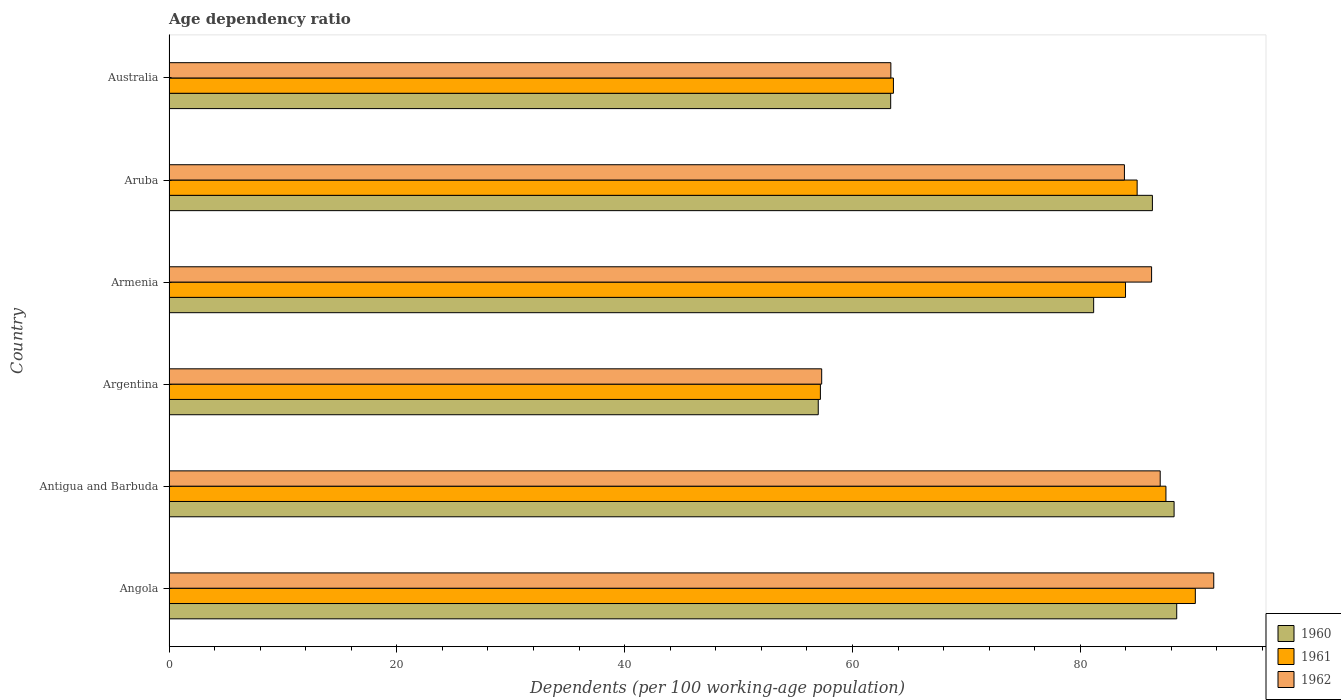Are the number of bars per tick equal to the number of legend labels?
Give a very brief answer. Yes. What is the label of the 2nd group of bars from the top?
Provide a short and direct response. Aruba. What is the age dependency ratio in in 1960 in Angola?
Keep it short and to the point. 88.47. Across all countries, what is the maximum age dependency ratio in in 1960?
Provide a succinct answer. 88.47. Across all countries, what is the minimum age dependency ratio in in 1962?
Provide a succinct answer. 57.3. In which country was the age dependency ratio in in 1960 maximum?
Offer a terse response. Angola. In which country was the age dependency ratio in in 1960 minimum?
Ensure brevity in your answer.  Argentina. What is the total age dependency ratio in in 1960 in the graph?
Your response must be concise. 464.57. What is the difference between the age dependency ratio in in 1961 in Angola and that in Argentina?
Your answer should be compact. 32.92. What is the difference between the age dependency ratio in in 1962 in Aruba and the age dependency ratio in in 1960 in Australia?
Make the answer very short. 20.52. What is the average age dependency ratio in in 1961 per country?
Give a very brief answer. 77.9. What is the difference between the age dependency ratio in in 1962 and age dependency ratio in in 1960 in Angola?
Offer a very short reply. 3.25. In how many countries, is the age dependency ratio in in 1961 greater than 8 %?
Ensure brevity in your answer.  6. What is the ratio of the age dependency ratio in in 1961 in Antigua and Barbuda to that in Aruba?
Offer a terse response. 1.03. Is the difference between the age dependency ratio in in 1962 in Armenia and Australia greater than the difference between the age dependency ratio in in 1960 in Armenia and Australia?
Your answer should be very brief. Yes. What is the difference between the highest and the second highest age dependency ratio in in 1962?
Your response must be concise. 4.7. What is the difference between the highest and the lowest age dependency ratio in in 1962?
Provide a succinct answer. 34.42. In how many countries, is the age dependency ratio in in 1960 greater than the average age dependency ratio in in 1960 taken over all countries?
Ensure brevity in your answer.  4. What does the 3rd bar from the top in Angola represents?
Keep it short and to the point. 1960. Is it the case that in every country, the sum of the age dependency ratio in in 1962 and age dependency ratio in in 1961 is greater than the age dependency ratio in in 1960?
Ensure brevity in your answer.  Yes. How many bars are there?
Your response must be concise. 18. Are the values on the major ticks of X-axis written in scientific E-notation?
Your answer should be compact. No. Does the graph contain any zero values?
Give a very brief answer. No. Does the graph contain grids?
Provide a succinct answer. No. How many legend labels are there?
Your answer should be compact. 3. What is the title of the graph?
Ensure brevity in your answer.  Age dependency ratio. What is the label or title of the X-axis?
Ensure brevity in your answer.  Dependents (per 100 working-age population). What is the Dependents (per 100 working-age population) in 1960 in Angola?
Keep it short and to the point. 88.47. What is the Dependents (per 100 working-age population) of 1961 in Angola?
Offer a terse response. 90.1. What is the Dependents (per 100 working-age population) in 1962 in Angola?
Provide a succinct answer. 91.72. What is the Dependents (per 100 working-age population) in 1960 in Antigua and Barbuda?
Give a very brief answer. 88.24. What is the Dependents (per 100 working-age population) in 1961 in Antigua and Barbuda?
Offer a very short reply. 87.52. What is the Dependents (per 100 working-age population) of 1962 in Antigua and Barbuda?
Provide a short and direct response. 87.02. What is the Dependents (per 100 working-age population) of 1960 in Argentina?
Offer a terse response. 57. What is the Dependents (per 100 working-age population) of 1961 in Argentina?
Your response must be concise. 57.19. What is the Dependents (per 100 working-age population) of 1962 in Argentina?
Make the answer very short. 57.3. What is the Dependents (per 100 working-age population) in 1960 in Armenia?
Provide a succinct answer. 81.18. What is the Dependents (per 100 working-age population) in 1961 in Armenia?
Your answer should be compact. 83.97. What is the Dependents (per 100 working-age population) in 1962 in Armenia?
Give a very brief answer. 86.26. What is the Dependents (per 100 working-age population) of 1960 in Aruba?
Give a very brief answer. 86.33. What is the Dependents (per 100 working-age population) in 1961 in Aruba?
Your answer should be very brief. 84.99. What is the Dependents (per 100 working-age population) in 1962 in Aruba?
Your answer should be very brief. 83.88. What is the Dependents (per 100 working-age population) in 1960 in Australia?
Keep it short and to the point. 63.36. What is the Dependents (per 100 working-age population) in 1961 in Australia?
Give a very brief answer. 63.6. What is the Dependents (per 100 working-age population) in 1962 in Australia?
Make the answer very short. 63.37. Across all countries, what is the maximum Dependents (per 100 working-age population) of 1960?
Provide a short and direct response. 88.47. Across all countries, what is the maximum Dependents (per 100 working-age population) in 1961?
Your answer should be very brief. 90.1. Across all countries, what is the maximum Dependents (per 100 working-age population) of 1962?
Offer a very short reply. 91.72. Across all countries, what is the minimum Dependents (per 100 working-age population) in 1960?
Offer a terse response. 57. Across all countries, what is the minimum Dependents (per 100 working-age population) in 1961?
Keep it short and to the point. 57.19. Across all countries, what is the minimum Dependents (per 100 working-age population) in 1962?
Keep it short and to the point. 57.3. What is the total Dependents (per 100 working-age population) of 1960 in the graph?
Give a very brief answer. 464.57. What is the total Dependents (per 100 working-age population) in 1961 in the graph?
Your response must be concise. 467.37. What is the total Dependents (per 100 working-age population) in 1962 in the graph?
Keep it short and to the point. 469.55. What is the difference between the Dependents (per 100 working-age population) in 1960 in Angola and that in Antigua and Barbuda?
Your answer should be very brief. 0.23. What is the difference between the Dependents (per 100 working-age population) of 1961 in Angola and that in Antigua and Barbuda?
Make the answer very short. 2.58. What is the difference between the Dependents (per 100 working-age population) in 1962 in Angola and that in Antigua and Barbuda?
Make the answer very short. 4.7. What is the difference between the Dependents (per 100 working-age population) in 1960 in Angola and that in Argentina?
Offer a terse response. 31.47. What is the difference between the Dependents (per 100 working-age population) in 1961 in Angola and that in Argentina?
Your answer should be very brief. 32.92. What is the difference between the Dependents (per 100 working-age population) of 1962 in Angola and that in Argentina?
Offer a terse response. 34.42. What is the difference between the Dependents (per 100 working-age population) of 1960 in Angola and that in Armenia?
Your answer should be very brief. 7.29. What is the difference between the Dependents (per 100 working-age population) of 1961 in Angola and that in Armenia?
Provide a short and direct response. 6.13. What is the difference between the Dependents (per 100 working-age population) in 1962 in Angola and that in Armenia?
Make the answer very short. 5.46. What is the difference between the Dependents (per 100 working-age population) of 1960 in Angola and that in Aruba?
Keep it short and to the point. 2.13. What is the difference between the Dependents (per 100 working-age population) in 1961 in Angola and that in Aruba?
Keep it short and to the point. 5.11. What is the difference between the Dependents (per 100 working-age population) in 1962 in Angola and that in Aruba?
Your response must be concise. 7.84. What is the difference between the Dependents (per 100 working-age population) in 1960 in Angola and that in Australia?
Ensure brevity in your answer.  25.11. What is the difference between the Dependents (per 100 working-age population) in 1961 in Angola and that in Australia?
Your response must be concise. 26.5. What is the difference between the Dependents (per 100 working-age population) in 1962 in Angola and that in Australia?
Your response must be concise. 28.35. What is the difference between the Dependents (per 100 working-age population) in 1960 in Antigua and Barbuda and that in Argentina?
Your answer should be compact. 31.24. What is the difference between the Dependents (per 100 working-age population) of 1961 in Antigua and Barbuda and that in Argentina?
Keep it short and to the point. 30.34. What is the difference between the Dependents (per 100 working-age population) of 1962 in Antigua and Barbuda and that in Argentina?
Offer a very short reply. 29.72. What is the difference between the Dependents (per 100 working-age population) of 1960 in Antigua and Barbuda and that in Armenia?
Offer a terse response. 7.06. What is the difference between the Dependents (per 100 working-age population) of 1961 in Antigua and Barbuda and that in Armenia?
Provide a short and direct response. 3.55. What is the difference between the Dependents (per 100 working-age population) in 1962 in Antigua and Barbuda and that in Armenia?
Your answer should be very brief. 0.76. What is the difference between the Dependents (per 100 working-age population) of 1960 in Antigua and Barbuda and that in Aruba?
Your response must be concise. 1.9. What is the difference between the Dependents (per 100 working-age population) of 1961 in Antigua and Barbuda and that in Aruba?
Offer a terse response. 2.53. What is the difference between the Dependents (per 100 working-age population) in 1962 in Antigua and Barbuda and that in Aruba?
Your answer should be very brief. 3.14. What is the difference between the Dependents (per 100 working-age population) of 1960 in Antigua and Barbuda and that in Australia?
Your response must be concise. 24.88. What is the difference between the Dependents (per 100 working-age population) in 1961 in Antigua and Barbuda and that in Australia?
Your answer should be compact. 23.92. What is the difference between the Dependents (per 100 working-age population) of 1962 in Antigua and Barbuda and that in Australia?
Offer a very short reply. 23.65. What is the difference between the Dependents (per 100 working-age population) of 1960 in Argentina and that in Armenia?
Ensure brevity in your answer.  -24.18. What is the difference between the Dependents (per 100 working-age population) of 1961 in Argentina and that in Armenia?
Offer a terse response. -26.79. What is the difference between the Dependents (per 100 working-age population) in 1962 in Argentina and that in Armenia?
Offer a terse response. -28.96. What is the difference between the Dependents (per 100 working-age population) of 1960 in Argentina and that in Aruba?
Ensure brevity in your answer.  -29.34. What is the difference between the Dependents (per 100 working-age population) in 1961 in Argentina and that in Aruba?
Keep it short and to the point. -27.81. What is the difference between the Dependents (per 100 working-age population) in 1962 in Argentina and that in Aruba?
Provide a short and direct response. -26.58. What is the difference between the Dependents (per 100 working-age population) in 1960 in Argentina and that in Australia?
Provide a succinct answer. -6.36. What is the difference between the Dependents (per 100 working-age population) in 1961 in Argentina and that in Australia?
Your answer should be very brief. -6.41. What is the difference between the Dependents (per 100 working-age population) of 1962 in Argentina and that in Australia?
Ensure brevity in your answer.  -6.07. What is the difference between the Dependents (per 100 working-age population) in 1960 in Armenia and that in Aruba?
Your answer should be compact. -5.16. What is the difference between the Dependents (per 100 working-age population) of 1961 in Armenia and that in Aruba?
Offer a terse response. -1.02. What is the difference between the Dependents (per 100 working-age population) of 1962 in Armenia and that in Aruba?
Provide a succinct answer. 2.39. What is the difference between the Dependents (per 100 working-age population) in 1960 in Armenia and that in Australia?
Provide a short and direct response. 17.82. What is the difference between the Dependents (per 100 working-age population) in 1961 in Armenia and that in Australia?
Offer a very short reply. 20.38. What is the difference between the Dependents (per 100 working-age population) in 1962 in Armenia and that in Australia?
Keep it short and to the point. 22.89. What is the difference between the Dependents (per 100 working-age population) in 1960 in Aruba and that in Australia?
Provide a short and direct response. 22.98. What is the difference between the Dependents (per 100 working-age population) of 1961 in Aruba and that in Australia?
Ensure brevity in your answer.  21.4. What is the difference between the Dependents (per 100 working-age population) in 1962 in Aruba and that in Australia?
Ensure brevity in your answer.  20.5. What is the difference between the Dependents (per 100 working-age population) of 1960 in Angola and the Dependents (per 100 working-age population) of 1961 in Antigua and Barbuda?
Provide a short and direct response. 0.95. What is the difference between the Dependents (per 100 working-age population) of 1960 in Angola and the Dependents (per 100 working-age population) of 1962 in Antigua and Barbuda?
Provide a succinct answer. 1.45. What is the difference between the Dependents (per 100 working-age population) of 1961 in Angola and the Dependents (per 100 working-age population) of 1962 in Antigua and Barbuda?
Provide a succinct answer. 3.08. What is the difference between the Dependents (per 100 working-age population) of 1960 in Angola and the Dependents (per 100 working-age population) of 1961 in Argentina?
Your answer should be very brief. 31.28. What is the difference between the Dependents (per 100 working-age population) in 1960 in Angola and the Dependents (per 100 working-age population) in 1962 in Argentina?
Your answer should be very brief. 31.17. What is the difference between the Dependents (per 100 working-age population) of 1961 in Angola and the Dependents (per 100 working-age population) of 1962 in Argentina?
Offer a terse response. 32.8. What is the difference between the Dependents (per 100 working-age population) of 1960 in Angola and the Dependents (per 100 working-age population) of 1961 in Armenia?
Your response must be concise. 4.49. What is the difference between the Dependents (per 100 working-age population) of 1960 in Angola and the Dependents (per 100 working-age population) of 1962 in Armenia?
Offer a terse response. 2.21. What is the difference between the Dependents (per 100 working-age population) of 1961 in Angola and the Dependents (per 100 working-age population) of 1962 in Armenia?
Offer a terse response. 3.84. What is the difference between the Dependents (per 100 working-age population) in 1960 in Angola and the Dependents (per 100 working-age population) in 1961 in Aruba?
Your answer should be compact. 3.47. What is the difference between the Dependents (per 100 working-age population) of 1960 in Angola and the Dependents (per 100 working-age population) of 1962 in Aruba?
Offer a very short reply. 4.59. What is the difference between the Dependents (per 100 working-age population) in 1961 in Angola and the Dependents (per 100 working-age population) in 1962 in Aruba?
Keep it short and to the point. 6.22. What is the difference between the Dependents (per 100 working-age population) in 1960 in Angola and the Dependents (per 100 working-age population) in 1961 in Australia?
Offer a very short reply. 24.87. What is the difference between the Dependents (per 100 working-age population) in 1960 in Angola and the Dependents (per 100 working-age population) in 1962 in Australia?
Make the answer very short. 25.1. What is the difference between the Dependents (per 100 working-age population) of 1961 in Angola and the Dependents (per 100 working-age population) of 1962 in Australia?
Give a very brief answer. 26.73. What is the difference between the Dependents (per 100 working-age population) of 1960 in Antigua and Barbuda and the Dependents (per 100 working-age population) of 1961 in Argentina?
Provide a succinct answer. 31.05. What is the difference between the Dependents (per 100 working-age population) in 1960 in Antigua and Barbuda and the Dependents (per 100 working-age population) in 1962 in Argentina?
Keep it short and to the point. 30.94. What is the difference between the Dependents (per 100 working-age population) of 1961 in Antigua and Barbuda and the Dependents (per 100 working-age population) of 1962 in Argentina?
Your answer should be very brief. 30.22. What is the difference between the Dependents (per 100 working-age population) of 1960 in Antigua and Barbuda and the Dependents (per 100 working-age population) of 1961 in Armenia?
Your answer should be compact. 4.26. What is the difference between the Dependents (per 100 working-age population) in 1960 in Antigua and Barbuda and the Dependents (per 100 working-age population) in 1962 in Armenia?
Offer a very short reply. 1.97. What is the difference between the Dependents (per 100 working-age population) in 1961 in Antigua and Barbuda and the Dependents (per 100 working-age population) in 1962 in Armenia?
Provide a succinct answer. 1.26. What is the difference between the Dependents (per 100 working-age population) in 1960 in Antigua and Barbuda and the Dependents (per 100 working-age population) in 1961 in Aruba?
Provide a succinct answer. 3.24. What is the difference between the Dependents (per 100 working-age population) in 1960 in Antigua and Barbuda and the Dependents (per 100 working-age population) in 1962 in Aruba?
Offer a very short reply. 4.36. What is the difference between the Dependents (per 100 working-age population) of 1961 in Antigua and Barbuda and the Dependents (per 100 working-age population) of 1962 in Aruba?
Make the answer very short. 3.64. What is the difference between the Dependents (per 100 working-age population) in 1960 in Antigua and Barbuda and the Dependents (per 100 working-age population) in 1961 in Australia?
Provide a succinct answer. 24.64. What is the difference between the Dependents (per 100 working-age population) in 1960 in Antigua and Barbuda and the Dependents (per 100 working-age population) in 1962 in Australia?
Provide a short and direct response. 24.86. What is the difference between the Dependents (per 100 working-age population) in 1961 in Antigua and Barbuda and the Dependents (per 100 working-age population) in 1962 in Australia?
Provide a short and direct response. 24.15. What is the difference between the Dependents (per 100 working-age population) of 1960 in Argentina and the Dependents (per 100 working-age population) of 1961 in Armenia?
Your answer should be very brief. -26.98. What is the difference between the Dependents (per 100 working-age population) in 1960 in Argentina and the Dependents (per 100 working-age population) in 1962 in Armenia?
Offer a terse response. -29.27. What is the difference between the Dependents (per 100 working-age population) in 1961 in Argentina and the Dependents (per 100 working-age population) in 1962 in Armenia?
Your answer should be compact. -29.08. What is the difference between the Dependents (per 100 working-age population) of 1960 in Argentina and the Dependents (per 100 working-age population) of 1961 in Aruba?
Your response must be concise. -28. What is the difference between the Dependents (per 100 working-age population) of 1960 in Argentina and the Dependents (per 100 working-age population) of 1962 in Aruba?
Provide a short and direct response. -26.88. What is the difference between the Dependents (per 100 working-age population) of 1961 in Argentina and the Dependents (per 100 working-age population) of 1962 in Aruba?
Offer a terse response. -26.69. What is the difference between the Dependents (per 100 working-age population) of 1960 in Argentina and the Dependents (per 100 working-age population) of 1961 in Australia?
Your answer should be very brief. -6.6. What is the difference between the Dependents (per 100 working-age population) of 1960 in Argentina and the Dependents (per 100 working-age population) of 1962 in Australia?
Make the answer very short. -6.38. What is the difference between the Dependents (per 100 working-age population) of 1961 in Argentina and the Dependents (per 100 working-age population) of 1962 in Australia?
Make the answer very short. -6.19. What is the difference between the Dependents (per 100 working-age population) of 1960 in Armenia and the Dependents (per 100 working-age population) of 1961 in Aruba?
Keep it short and to the point. -3.82. What is the difference between the Dependents (per 100 working-age population) in 1960 in Armenia and the Dependents (per 100 working-age population) in 1962 in Aruba?
Ensure brevity in your answer.  -2.7. What is the difference between the Dependents (per 100 working-age population) in 1961 in Armenia and the Dependents (per 100 working-age population) in 1962 in Aruba?
Provide a short and direct response. 0.1. What is the difference between the Dependents (per 100 working-age population) of 1960 in Armenia and the Dependents (per 100 working-age population) of 1961 in Australia?
Make the answer very short. 17.58. What is the difference between the Dependents (per 100 working-age population) in 1960 in Armenia and the Dependents (per 100 working-age population) in 1962 in Australia?
Your answer should be very brief. 17.8. What is the difference between the Dependents (per 100 working-age population) of 1961 in Armenia and the Dependents (per 100 working-age population) of 1962 in Australia?
Keep it short and to the point. 20.6. What is the difference between the Dependents (per 100 working-age population) in 1960 in Aruba and the Dependents (per 100 working-age population) in 1961 in Australia?
Provide a succinct answer. 22.74. What is the difference between the Dependents (per 100 working-age population) of 1960 in Aruba and the Dependents (per 100 working-age population) of 1962 in Australia?
Provide a short and direct response. 22.96. What is the difference between the Dependents (per 100 working-age population) of 1961 in Aruba and the Dependents (per 100 working-age population) of 1962 in Australia?
Ensure brevity in your answer.  21.62. What is the average Dependents (per 100 working-age population) of 1960 per country?
Offer a very short reply. 77.43. What is the average Dependents (per 100 working-age population) of 1961 per country?
Make the answer very short. 77.89. What is the average Dependents (per 100 working-age population) in 1962 per country?
Ensure brevity in your answer.  78.26. What is the difference between the Dependents (per 100 working-age population) in 1960 and Dependents (per 100 working-age population) in 1961 in Angola?
Your answer should be compact. -1.63. What is the difference between the Dependents (per 100 working-age population) of 1960 and Dependents (per 100 working-age population) of 1962 in Angola?
Keep it short and to the point. -3.25. What is the difference between the Dependents (per 100 working-age population) of 1961 and Dependents (per 100 working-age population) of 1962 in Angola?
Your response must be concise. -1.62. What is the difference between the Dependents (per 100 working-age population) of 1960 and Dependents (per 100 working-age population) of 1961 in Antigua and Barbuda?
Your response must be concise. 0.72. What is the difference between the Dependents (per 100 working-age population) of 1960 and Dependents (per 100 working-age population) of 1962 in Antigua and Barbuda?
Your answer should be very brief. 1.22. What is the difference between the Dependents (per 100 working-age population) in 1961 and Dependents (per 100 working-age population) in 1962 in Antigua and Barbuda?
Keep it short and to the point. 0.5. What is the difference between the Dependents (per 100 working-age population) in 1960 and Dependents (per 100 working-age population) in 1961 in Argentina?
Give a very brief answer. -0.19. What is the difference between the Dependents (per 100 working-age population) in 1960 and Dependents (per 100 working-age population) in 1962 in Argentina?
Ensure brevity in your answer.  -0.3. What is the difference between the Dependents (per 100 working-age population) of 1961 and Dependents (per 100 working-age population) of 1962 in Argentina?
Your answer should be very brief. -0.11. What is the difference between the Dependents (per 100 working-age population) in 1960 and Dependents (per 100 working-age population) in 1961 in Armenia?
Your answer should be very brief. -2.8. What is the difference between the Dependents (per 100 working-age population) of 1960 and Dependents (per 100 working-age population) of 1962 in Armenia?
Your answer should be compact. -5.09. What is the difference between the Dependents (per 100 working-age population) in 1961 and Dependents (per 100 working-age population) in 1962 in Armenia?
Your answer should be very brief. -2.29. What is the difference between the Dependents (per 100 working-age population) of 1960 and Dependents (per 100 working-age population) of 1961 in Aruba?
Keep it short and to the point. 1.34. What is the difference between the Dependents (per 100 working-age population) in 1960 and Dependents (per 100 working-age population) in 1962 in Aruba?
Provide a short and direct response. 2.46. What is the difference between the Dependents (per 100 working-age population) in 1961 and Dependents (per 100 working-age population) in 1962 in Aruba?
Ensure brevity in your answer.  1.12. What is the difference between the Dependents (per 100 working-age population) of 1960 and Dependents (per 100 working-age population) of 1961 in Australia?
Your response must be concise. -0.24. What is the difference between the Dependents (per 100 working-age population) of 1960 and Dependents (per 100 working-age population) of 1962 in Australia?
Keep it short and to the point. -0.02. What is the difference between the Dependents (per 100 working-age population) in 1961 and Dependents (per 100 working-age population) in 1962 in Australia?
Make the answer very short. 0.22. What is the ratio of the Dependents (per 100 working-age population) in 1960 in Angola to that in Antigua and Barbuda?
Ensure brevity in your answer.  1. What is the ratio of the Dependents (per 100 working-age population) in 1961 in Angola to that in Antigua and Barbuda?
Provide a succinct answer. 1.03. What is the ratio of the Dependents (per 100 working-age population) in 1962 in Angola to that in Antigua and Barbuda?
Your answer should be compact. 1.05. What is the ratio of the Dependents (per 100 working-age population) in 1960 in Angola to that in Argentina?
Offer a terse response. 1.55. What is the ratio of the Dependents (per 100 working-age population) in 1961 in Angola to that in Argentina?
Provide a succinct answer. 1.58. What is the ratio of the Dependents (per 100 working-age population) in 1962 in Angola to that in Argentina?
Your response must be concise. 1.6. What is the ratio of the Dependents (per 100 working-age population) of 1960 in Angola to that in Armenia?
Offer a terse response. 1.09. What is the ratio of the Dependents (per 100 working-age population) in 1961 in Angola to that in Armenia?
Your response must be concise. 1.07. What is the ratio of the Dependents (per 100 working-age population) in 1962 in Angola to that in Armenia?
Offer a terse response. 1.06. What is the ratio of the Dependents (per 100 working-age population) of 1960 in Angola to that in Aruba?
Keep it short and to the point. 1.02. What is the ratio of the Dependents (per 100 working-age population) in 1961 in Angola to that in Aruba?
Your answer should be very brief. 1.06. What is the ratio of the Dependents (per 100 working-age population) of 1962 in Angola to that in Aruba?
Provide a succinct answer. 1.09. What is the ratio of the Dependents (per 100 working-age population) in 1960 in Angola to that in Australia?
Your answer should be very brief. 1.4. What is the ratio of the Dependents (per 100 working-age population) in 1961 in Angola to that in Australia?
Make the answer very short. 1.42. What is the ratio of the Dependents (per 100 working-age population) in 1962 in Angola to that in Australia?
Give a very brief answer. 1.45. What is the ratio of the Dependents (per 100 working-age population) in 1960 in Antigua and Barbuda to that in Argentina?
Offer a terse response. 1.55. What is the ratio of the Dependents (per 100 working-age population) of 1961 in Antigua and Barbuda to that in Argentina?
Provide a succinct answer. 1.53. What is the ratio of the Dependents (per 100 working-age population) in 1962 in Antigua and Barbuda to that in Argentina?
Your answer should be very brief. 1.52. What is the ratio of the Dependents (per 100 working-age population) in 1960 in Antigua and Barbuda to that in Armenia?
Give a very brief answer. 1.09. What is the ratio of the Dependents (per 100 working-age population) of 1961 in Antigua and Barbuda to that in Armenia?
Provide a short and direct response. 1.04. What is the ratio of the Dependents (per 100 working-age population) of 1962 in Antigua and Barbuda to that in Armenia?
Provide a succinct answer. 1.01. What is the ratio of the Dependents (per 100 working-age population) of 1960 in Antigua and Barbuda to that in Aruba?
Your answer should be compact. 1.02. What is the ratio of the Dependents (per 100 working-age population) in 1961 in Antigua and Barbuda to that in Aruba?
Your response must be concise. 1.03. What is the ratio of the Dependents (per 100 working-age population) in 1962 in Antigua and Barbuda to that in Aruba?
Your answer should be very brief. 1.04. What is the ratio of the Dependents (per 100 working-age population) in 1960 in Antigua and Barbuda to that in Australia?
Offer a very short reply. 1.39. What is the ratio of the Dependents (per 100 working-age population) of 1961 in Antigua and Barbuda to that in Australia?
Provide a succinct answer. 1.38. What is the ratio of the Dependents (per 100 working-age population) of 1962 in Antigua and Barbuda to that in Australia?
Your answer should be compact. 1.37. What is the ratio of the Dependents (per 100 working-age population) in 1960 in Argentina to that in Armenia?
Your answer should be compact. 0.7. What is the ratio of the Dependents (per 100 working-age population) in 1961 in Argentina to that in Armenia?
Keep it short and to the point. 0.68. What is the ratio of the Dependents (per 100 working-age population) in 1962 in Argentina to that in Armenia?
Give a very brief answer. 0.66. What is the ratio of the Dependents (per 100 working-age population) of 1960 in Argentina to that in Aruba?
Provide a short and direct response. 0.66. What is the ratio of the Dependents (per 100 working-age population) of 1961 in Argentina to that in Aruba?
Offer a terse response. 0.67. What is the ratio of the Dependents (per 100 working-age population) of 1962 in Argentina to that in Aruba?
Provide a short and direct response. 0.68. What is the ratio of the Dependents (per 100 working-age population) in 1960 in Argentina to that in Australia?
Offer a terse response. 0.9. What is the ratio of the Dependents (per 100 working-age population) in 1961 in Argentina to that in Australia?
Make the answer very short. 0.9. What is the ratio of the Dependents (per 100 working-age population) in 1962 in Argentina to that in Australia?
Make the answer very short. 0.9. What is the ratio of the Dependents (per 100 working-age population) of 1960 in Armenia to that in Aruba?
Keep it short and to the point. 0.94. What is the ratio of the Dependents (per 100 working-age population) of 1961 in Armenia to that in Aruba?
Your answer should be very brief. 0.99. What is the ratio of the Dependents (per 100 working-age population) of 1962 in Armenia to that in Aruba?
Offer a terse response. 1.03. What is the ratio of the Dependents (per 100 working-age population) of 1960 in Armenia to that in Australia?
Keep it short and to the point. 1.28. What is the ratio of the Dependents (per 100 working-age population) in 1961 in Armenia to that in Australia?
Your answer should be compact. 1.32. What is the ratio of the Dependents (per 100 working-age population) in 1962 in Armenia to that in Australia?
Your answer should be very brief. 1.36. What is the ratio of the Dependents (per 100 working-age population) in 1960 in Aruba to that in Australia?
Provide a short and direct response. 1.36. What is the ratio of the Dependents (per 100 working-age population) in 1961 in Aruba to that in Australia?
Make the answer very short. 1.34. What is the ratio of the Dependents (per 100 working-age population) in 1962 in Aruba to that in Australia?
Provide a succinct answer. 1.32. What is the difference between the highest and the second highest Dependents (per 100 working-age population) of 1960?
Offer a very short reply. 0.23. What is the difference between the highest and the second highest Dependents (per 100 working-age population) of 1961?
Your answer should be very brief. 2.58. What is the difference between the highest and the second highest Dependents (per 100 working-age population) in 1962?
Provide a succinct answer. 4.7. What is the difference between the highest and the lowest Dependents (per 100 working-age population) of 1960?
Provide a short and direct response. 31.47. What is the difference between the highest and the lowest Dependents (per 100 working-age population) of 1961?
Offer a terse response. 32.92. What is the difference between the highest and the lowest Dependents (per 100 working-age population) of 1962?
Offer a terse response. 34.42. 